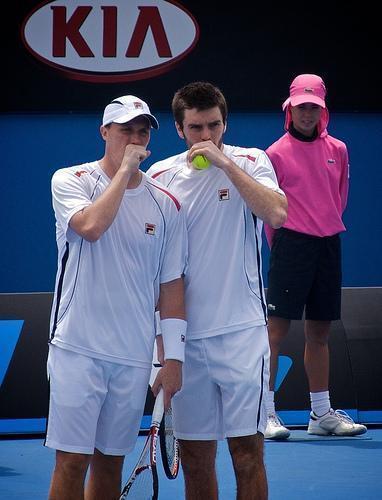Why are they covering their mouths?
Select the correct answer and articulate reasoning with the following format: 'Answer: answer
Rationale: rationale.'
Options: Are laughing, are eating, conceal conversation, are coughing. Answer: conceal conversation.
Rationale: The men are talking and concealing their mouths. 